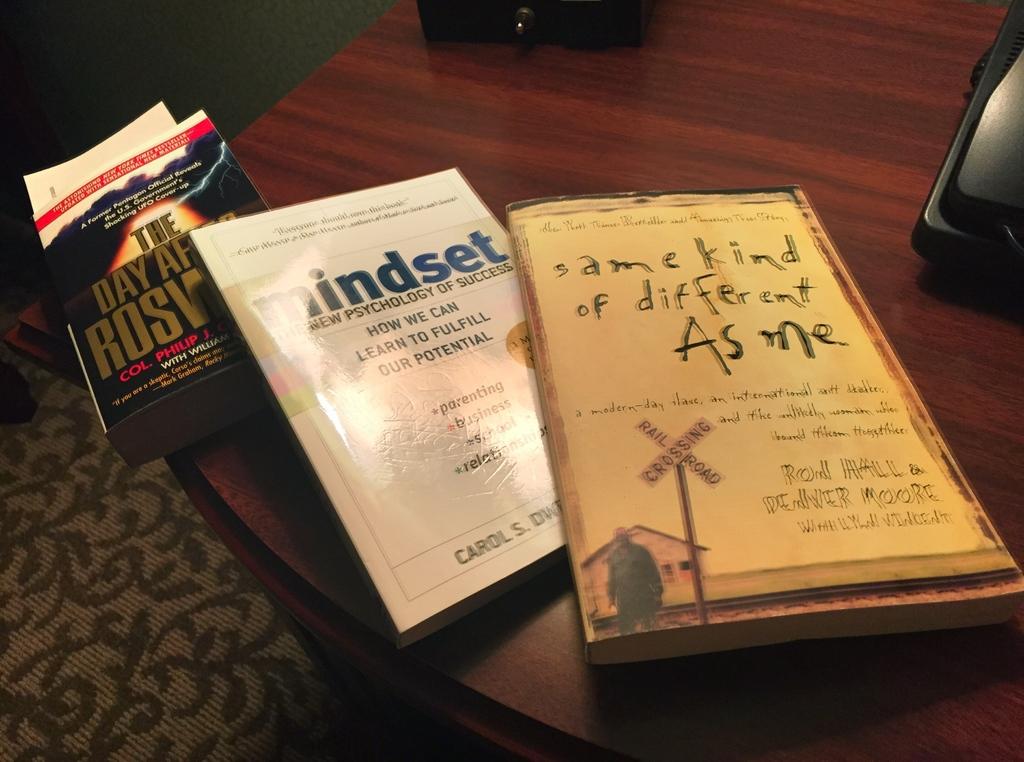What is the name of the book with a railroad crossing on it?
Ensure brevity in your answer.  Same kind of different as me. Who authored same kind of different as me?
Ensure brevity in your answer.  Unanswerable. 